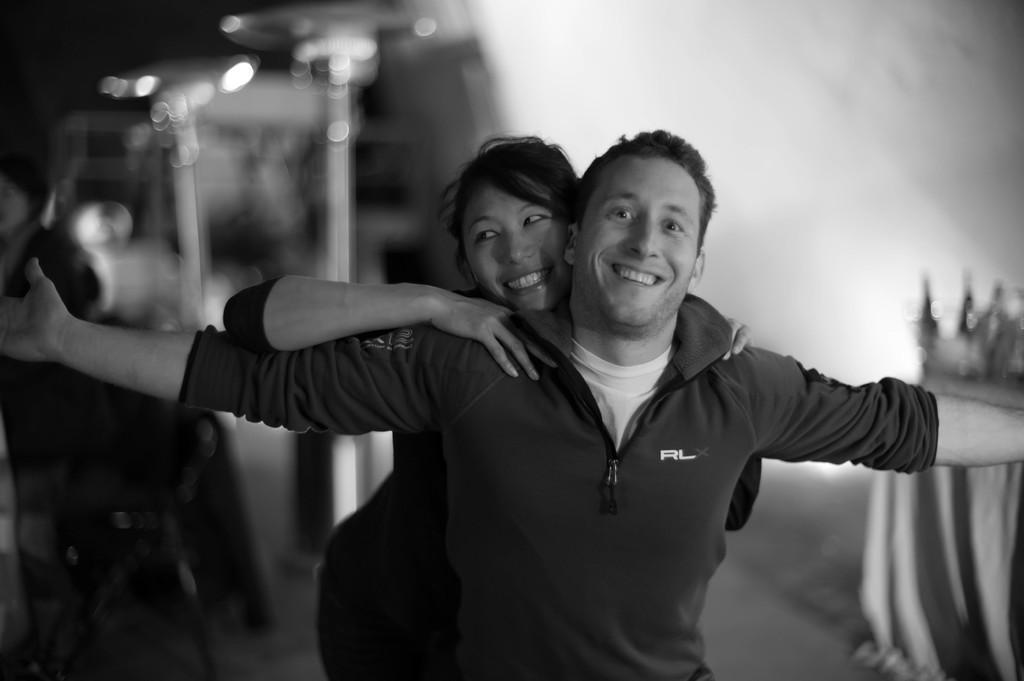In one or two sentences, can you explain what this image depicts? In this picture we can see a man and a woman smiling and in the background it is blurry. 